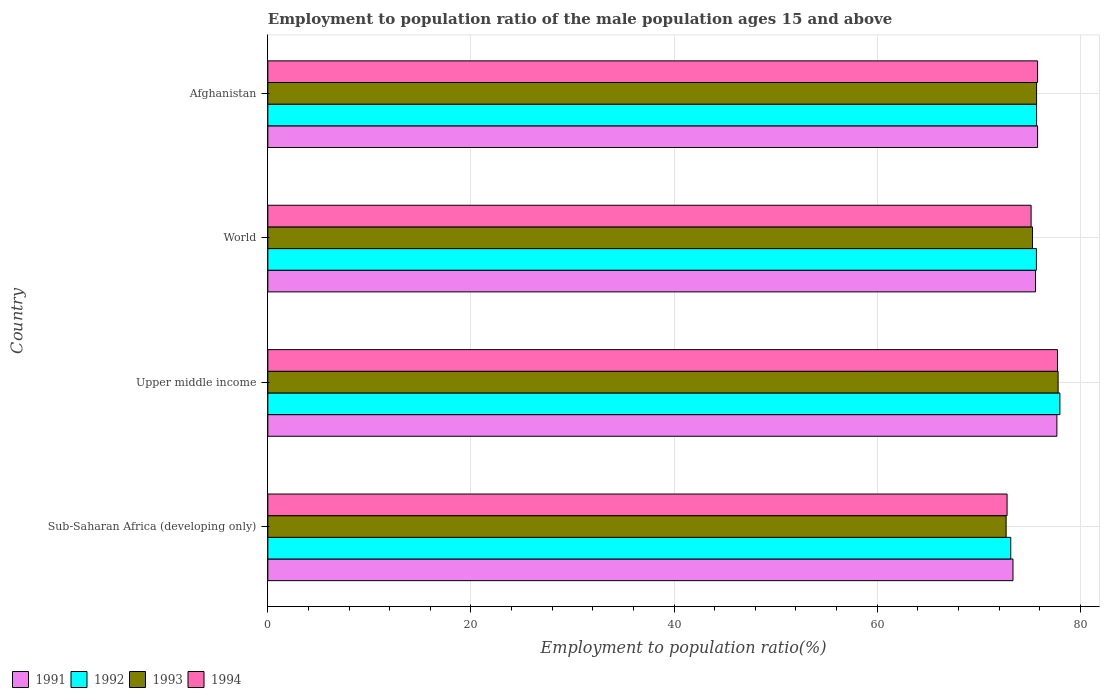How many groups of bars are there?
Make the answer very short. 4. Are the number of bars per tick equal to the number of legend labels?
Your answer should be compact. Yes. Are the number of bars on each tick of the Y-axis equal?
Make the answer very short. Yes. How many bars are there on the 3rd tick from the top?
Make the answer very short. 4. What is the label of the 4th group of bars from the top?
Your answer should be compact. Sub-Saharan Africa (developing only). In how many cases, is the number of bars for a given country not equal to the number of legend labels?
Provide a succinct answer. 0. What is the employment to population ratio in 1994 in World?
Give a very brief answer. 75.16. Across all countries, what is the maximum employment to population ratio in 1992?
Offer a very short reply. 78. Across all countries, what is the minimum employment to population ratio in 1991?
Offer a terse response. 73.38. In which country was the employment to population ratio in 1993 maximum?
Your answer should be very brief. Upper middle income. In which country was the employment to population ratio in 1993 minimum?
Provide a short and direct response. Sub-Saharan Africa (developing only). What is the total employment to population ratio in 1993 in the graph?
Provide a short and direct response. 301.52. What is the difference between the employment to population ratio in 1993 in Sub-Saharan Africa (developing only) and that in Upper middle income?
Ensure brevity in your answer.  -5.12. What is the difference between the employment to population ratio in 1994 in Sub-Saharan Africa (developing only) and the employment to population ratio in 1992 in World?
Ensure brevity in your answer.  -2.89. What is the average employment to population ratio in 1994 per country?
Keep it short and to the point. 75.38. What is the difference between the employment to population ratio in 1994 and employment to population ratio in 1992 in Sub-Saharan Africa (developing only)?
Make the answer very short. -0.36. In how many countries, is the employment to population ratio in 1991 greater than 52 %?
Offer a terse response. 4. What is the ratio of the employment to population ratio in 1991 in Afghanistan to that in Sub-Saharan Africa (developing only)?
Offer a very short reply. 1.03. Is the employment to population ratio in 1991 in Sub-Saharan Africa (developing only) less than that in World?
Give a very brief answer. Yes. Is the difference between the employment to population ratio in 1994 in Upper middle income and World greater than the difference between the employment to population ratio in 1992 in Upper middle income and World?
Your answer should be compact. Yes. What is the difference between the highest and the second highest employment to population ratio in 1993?
Your answer should be very brief. 2.12. What is the difference between the highest and the lowest employment to population ratio in 1991?
Offer a very short reply. 4.32. In how many countries, is the employment to population ratio in 1991 greater than the average employment to population ratio in 1991 taken over all countries?
Ensure brevity in your answer.  2. Is it the case that in every country, the sum of the employment to population ratio in 1994 and employment to population ratio in 1993 is greater than the sum of employment to population ratio in 1992 and employment to population ratio in 1991?
Make the answer very short. No. What is the difference between two consecutive major ticks on the X-axis?
Your response must be concise. 20. Are the values on the major ticks of X-axis written in scientific E-notation?
Make the answer very short. No. Does the graph contain any zero values?
Keep it short and to the point. No. Does the graph contain grids?
Keep it short and to the point. Yes. What is the title of the graph?
Give a very brief answer. Employment to population ratio of the male population ages 15 and above. Does "1994" appear as one of the legend labels in the graph?
Provide a short and direct response. Yes. What is the label or title of the X-axis?
Keep it short and to the point. Employment to population ratio(%). What is the Employment to population ratio(%) of 1991 in Sub-Saharan Africa (developing only)?
Keep it short and to the point. 73.38. What is the Employment to population ratio(%) in 1992 in Sub-Saharan Africa (developing only)?
Your answer should be very brief. 73.16. What is the Employment to population ratio(%) in 1993 in Sub-Saharan Africa (developing only)?
Your response must be concise. 72.7. What is the Employment to population ratio(%) of 1994 in Sub-Saharan Africa (developing only)?
Your response must be concise. 72.8. What is the Employment to population ratio(%) of 1991 in Upper middle income?
Ensure brevity in your answer.  77.7. What is the Employment to population ratio(%) of 1992 in Upper middle income?
Your answer should be compact. 78. What is the Employment to population ratio(%) of 1993 in Upper middle income?
Make the answer very short. 77.82. What is the Employment to population ratio(%) of 1994 in Upper middle income?
Ensure brevity in your answer.  77.76. What is the Employment to population ratio(%) of 1991 in World?
Offer a very short reply. 75.6. What is the Employment to population ratio(%) of 1992 in World?
Provide a short and direct response. 75.69. What is the Employment to population ratio(%) in 1993 in World?
Provide a short and direct response. 75.3. What is the Employment to population ratio(%) in 1994 in World?
Your answer should be very brief. 75.16. What is the Employment to population ratio(%) in 1991 in Afghanistan?
Make the answer very short. 75.8. What is the Employment to population ratio(%) of 1992 in Afghanistan?
Offer a very short reply. 75.7. What is the Employment to population ratio(%) in 1993 in Afghanistan?
Your answer should be very brief. 75.7. What is the Employment to population ratio(%) in 1994 in Afghanistan?
Provide a short and direct response. 75.8. Across all countries, what is the maximum Employment to population ratio(%) in 1991?
Provide a short and direct response. 77.7. Across all countries, what is the maximum Employment to population ratio(%) in 1992?
Make the answer very short. 78. Across all countries, what is the maximum Employment to population ratio(%) of 1993?
Ensure brevity in your answer.  77.82. Across all countries, what is the maximum Employment to population ratio(%) in 1994?
Your answer should be compact. 77.76. Across all countries, what is the minimum Employment to population ratio(%) of 1991?
Give a very brief answer. 73.38. Across all countries, what is the minimum Employment to population ratio(%) of 1992?
Provide a short and direct response. 73.16. Across all countries, what is the minimum Employment to population ratio(%) of 1993?
Your response must be concise. 72.7. Across all countries, what is the minimum Employment to population ratio(%) in 1994?
Your response must be concise. 72.8. What is the total Employment to population ratio(%) in 1991 in the graph?
Give a very brief answer. 302.47. What is the total Employment to population ratio(%) in 1992 in the graph?
Your answer should be compact. 302.54. What is the total Employment to population ratio(%) of 1993 in the graph?
Ensure brevity in your answer.  301.52. What is the total Employment to population ratio(%) in 1994 in the graph?
Keep it short and to the point. 301.52. What is the difference between the Employment to population ratio(%) in 1991 in Sub-Saharan Africa (developing only) and that in Upper middle income?
Your response must be concise. -4.32. What is the difference between the Employment to population ratio(%) in 1992 in Sub-Saharan Africa (developing only) and that in Upper middle income?
Keep it short and to the point. -4.84. What is the difference between the Employment to population ratio(%) of 1993 in Sub-Saharan Africa (developing only) and that in Upper middle income?
Ensure brevity in your answer.  -5.12. What is the difference between the Employment to population ratio(%) in 1994 in Sub-Saharan Africa (developing only) and that in Upper middle income?
Provide a succinct answer. -4.97. What is the difference between the Employment to population ratio(%) of 1991 in Sub-Saharan Africa (developing only) and that in World?
Your answer should be very brief. -2.22. What is the difference between the Employment to population ratio(%) of 1992 in Sub-Saharan Africa (developing only) and that in World?
Ensure brevity in your answer.  -2.53. What is the difference between the Employment to population ratio(%) in 1993 in Sub-Saharan Africa (developing only) and that in World?
Offer a very short reply. -2.6. What is the difference between the Employment to population ratio(%) in 1994 in Sub-Saharan Africa (developing only) and that in World?
Your answer should be very brief. -2.37. What is the difference between the Employment to population ratio(%) in 1991 in Sub-Saharan Africa (developing only) and that in Afghanistan?
Ensure brevity in your answer.  -2.42. What is the difference between the Employment to population ratio(%) in 1992 in Sub-Saharan Africa (developing only) and that in Afghanistan?
Give a very brief answer. -2.54. What is the difference between the Employment to population ratio(%) in 1993 in Sub-Saharan Africa (developing only) and that in Afghanistan?
Ensure brevity in your answer.  -3. What is the difference between the Employment to population ratio(%) of 1994 in Sub-Saharan Africa (developing only) and that in Afghanistan?
Ensure brevity in your answer.  -3. What is the difference between the Employment to population ratio(%) in 1991 in Upper middle income and that in World?
Offer a terse response. 2.1. What is the difference between the Employment to population ratio(%) of 1992 in Upper middle income and that in World?
Provide a succinct answer. 2.31. What is the difference between the Employment to population ratio(%) of 1993 in Upper middle income and that in World?
Ensure brevity in your answer.  2.52. What is the difference between the Employment to population ratio(%) in 1994 in Upper middle income and that in World?
Offer a very short reply. 2.6. What is the difference between the Employment to population ratio(%) in 1991 in Upper middle income and that in Afghanistan?
Provide a succinct answer. 1.9. What is the difference between the Employment to population ratio(%) in 1992 in Upper middle income and that in Afghanistan?
Offer a terse response. 2.3. What is the difference between the Employment to population ratio(%) in 1993 in Upper middle income and that in Afghanistan?
Your response must be concise. 2.12. What is the difference between the Employment to population ratio(%) of 1994 in Upper middle income and that in Afghanistan?
Give a very brief answer. 1.96. What is the difference between the Employment to population ratio(%) of 1991 in World and that in Afghanistan?
Provide a succinct answer. -0.2. What is the difference between the Employment to population ratio(%) of 1992 in World and that in Afghanistan?
Provide a short and direct response. -0.01. What is the difference between the Employment to population ratio(%) of 1993 in World and that in Afghanistan?
Your answer should be very brief. -0.4. What is the difference between the Employment to population ratio(%) of 1994 in World and that in Afghanistan?
Ensure brevity in your answer.  -0.64. What is the difference between the Employment to population ratio(%) in 1991 in Sub-Saharan Africa (developing only) and the Employment to population ratio(%) in 1992 in Upper middle income?
Your answer should be very brief. -4.62. What is the difference between the Employment to population ratio(%) of 1991 in Sub-Saharan Africa (developing only) and the Employment to population ratio(%) of 1993 in Upper middle income?
Your answer should be compact. -4.44. What is the difference between the Employment to population ratio(%) of 1991 in Sub-Saharan Africa (developing only) and the Employment to population ratio(%) of 1994 in Upper middle income?
Offer a very short reply. -4.39. What is the difference between the Employment to population ratio(%) of 1992 in Sub-Saharan Africa (developing only) and the Employment to population ratio(%) of 1993 in Upper middle income?
Give a very brief answer. -4.66. What is the difference between the Employment to population ratio(%) in 1992 in Sub-Saharan Africa (developing only) and the Employment to population ratio(%) in 1994 in Upper middle income?
Offer a very short reply. -4.61. What is the difference between the Employment to population ratio(%) in 1993 in Sub-Saharan Africa (developing only) and the Employment to population ratio(%) in 1994 in Upper middle income?
Offer a very short reply. -5.06. What is the difference between the Employment to population ratio(%) of 1991 in Sub-Saharan Africa (developing only) and the Employment to population ratio(%) of 1992 in World?
Your answer should be very brief. -2.31. What is the difference between the Employment to population ratio(%) in 1991 in Sub-Saharan Africa (developing only) and the Employment to population ratio(%) in 1993 in World?
Offer a terse response. -1.93. What is the difference between the Employment to population ratio(%) in 1991 in Sub-Saharan Africa (developing only) and the Employment to population ratio(%) in 1994 in World?
Keep it short and to the point. -1.79. What is the difference between the Employment to population ratio(%) in 1992 in Sub-Saharan Africa (developing only) and the Employment to population ratio(%) in 1993 in World?
Your answer should be very brief. -2.14. What is the difference between the Employment to population ratio(%) of 1992 in Sub-Saharan Africa (developing only) and the Employment to population ratio(%) of 1994 in World?
Provide a succinct answer. -2. What is the difference between the Employment to population ratio(%) of 1993 in Sub-Saharan Africa (developing only) and the Employment to population ratio(%) of 1994 in World?
Offer a very short reply. -2.46. What is the difference between the Employment to population ratio(%) in 1991 in Sub-Saharan Africa (developing only) and the Employment to population ratio(%) in 1992 in Afghanistan?
Make the answer very short. -2.32. What is the difference between the Employment to population ratio(%) in 1991 in Sub-Saharan Africa (developing only) and the Employment to population ratio(%) in 1993 in Afghanistan?
Your answer should be very brief. -2.32. What is the difference between the Employment to population ratio(%) in 1991 in Sub-Saharan Africa (developing only) and the Employment to population ratio(%) in 1994 in Afghanistan?
Offer a terse response. -2.42. What is the difference between the Employment to population ratio(%) of 1992 in Sub-Saharan Africa (developing only) and the Employment to population ratio(%) of 1993 in Afghanistan?
Your answer should be very brief. -2.54. What is the difference between the Employment to population ratio(%) of 1992 in Sub-Saharan Africa (developing only) and the Employment to population ratio(%) of 1994 in Afghanistan?
Offer a terse response. -2.64. What is the difference between the Employment to population ratio(%) of 1993 in Sub-Saharan Africa (developing only) and the Employment to population ratio(%) of 1994 in Afghanistan?
Your answer should be compact. -3.1. What is the difference between the Employment to population ratio(%) in 1991 in Upper middle income and the Employment to population ratio(%) in 1992 in World?
Provide a succinct answer. 2.01. What is the difference between the Employment to population ratio(%) of 1991 in Upper middle income and the Employment to population ratio(%) of 1993 in World?
Offer a very short reply. 2.4. What is the difference between the Employment to population ratio(%) of 1991 in Upper middle income and the Employment to population ratio(%) of 1994 in World?
Ensure brevity in your answer.  2.54. What is the difference between the Employment to population ratio(%) of 1992 in Upper middle income and the Employment to population ratio(%) of 1993 in World?
Your answer should be compact. 2.69. What is the difference between the Employment to population ratio(%) of 1992 in Upper middle income and the Employment to population ratio(%) of 1994 in World?
Offer a very short reply. 2.83. What is the difference between the Employment to population ratio(%) in 1993 in Upper middle income and the Employment to population ratio(%) in 1994 in World?
Give a very brief answer. 2.66. What is the difference between the Employment to population ratio(%) in 1991 in Upper middle income and the Employment to population ratio(%) in 1992 in Afghanistan?
Offer a very short reply. 2. What is the difference between the Employment to population ratio(%) of 1991 in Upper middle income and the Employment to population ratio(%) of 1993 in Afghanistan?
Provide a succinct answer. 2. What is the difference between the Employment to population ratio(%) of 1991 in Upper middle income and the Employment to population ratio(%) of 1994 in Afghanistan?
Your answer should be very brief. 1.9. What is the difference between the Employment to population ratio(%) of 1992 in Upper middle income and the Employment to population ratio(%) of 1993 in Afghanistan?
Ensure brevity in your answer.  2.3. What is the difference between the Employment to population ratio(%) in 1992 in Upper middle income and the Employment to population ratio(%) in 1994 in Afghanistan?
Offer a very short reply. 2.2. What is the difference between the Employment to population ratio(%) of 1993 in Upper middle income and the Employment to population ratio(%) of 1994 in Afghanistan?
Provide a succinct answer. 2.02. What is the difference between the Employment to population ratio(%) of 1991 in World and the Employment to population ratio(%) of 1992 in Afghanistan?
Give a very brief answer. -0.1. What is the difference between the Employment to population ratio(%) in 1991 in World and the Employment to population ratio(%) in 1993 in Afghanistan?
Make the answer very short. -0.1. What is the difference between the Employment to population ratio(%) of 1991 in World and the Employment to population ratio(%) of 1994 in Afghanistan?
Give a very brief answer. -0.2. What is the difference between the Employment to population ratio(%) in 1992 in World and the Employment to population ratio(%) in 1993 in Afghanistan?
Make the answer very short. -0.01. What is the difference between the Employment to population ratio(%) in 1992 in World and the Employment to population ratio(%) in 1994 in Afghanistan?
Give a very brief answer. -0.11. What is the difference between the Employment to population ratio(%) in 1993 in World and the Employment to population ratio(%) in 1994 in Afghanistan?
Offer a very short reply. -0.5. What is the average Employment to population ratio(%) in 1991 per country?
Your response must be concise. 75.62. What is the average Employment to population ratio(%) in 1992 per country?
Provide a succinct answer. 75.63. What is the average Employment to population ratio(%) in 1993 per country?
Offer a very short reply. 75.38. What is the average Employment to population ratio(%) of 1994 per country?
Provide a succinct answer. 75.38. What is the difference between the Employment to population ratio(%) in 1991 and Employment to population ratio(%) in 1992 in Sub-Saharan Africa (developing only)?
Offer a very short reply. 0.22. What is the difference between the Employment to population ratio(%) in 1991 and Employment to population ratio(%) in 1993 in Sub-Saharan Africa (developing only)?
Your answer should be very brief. 0.67. What is the difference between the Employment to population ratio(%) in 1991 and Employment to population ratio(%) in 1994 in Sub-Saharan Africa (developing only)?
Keep it short and to the point. 0.58. What is the difference between the Employment to population ratio(%) of 1992 and Employment to population ratio(%) of 1993 in Sub-Saharan Africa (developing only)?
Provide a short and direct response. 0.46. What is the difference between the Employment to population ratio(%) of 1992 and Employment to population ratio(%) of 1994 in Sub-Saharan Africa (developing only)?
Make the answer very short. 0.36. What is the difference between the Employment to population ratio(%) in 1993 and Employment to population ratio(%) in 1994 in Sub-Saharan Africa (developing only)?
Offer a very short reply. -0.09. What is the difference between the Employment to population ratio(%) in 1991 and Employment to population ratio(%) in 1992 in Upper middle income?
Your answer should be compact. -0.3. What is the difference between the Employment to population ratio(%) of 1991 and Employment to population ratio(%) of 1993 in Upper middle income?
Your answer should be very brief. -0.12. What is the difference between the Employment to population ratio(%) in 1991 and Employment to population ratio(%) in 1994 in Upper middle income?
Your answer should be compact. -0.06. What is the difference between the Employment to population ratio(%) of 1992 and Employment to population ratio(%) of 1993 in Upper middle income?
Your answer should be compact. 0.18. What is the difference between the Employment to population ratio(%) of 1992 and Employment to population ratio(%) of 1994 in Upper middle income?
Ensure brevity in your answer.  0.23. What is the difference between the Employment to population ratio(%) of 1993 and Employment to population ratio(%) of 1994 in Upper middle income?
Make the answer very short. 0.06. What is the difference between the Employment to population ratio(%) in 1991 and Employment to population ratio(%) in 1992 in World?
Offer a terse response. -0.09. What is the difference between the Employment to population ratio(%) of 1991 and Employment to population ratio(%) of 1993 in World?
Your response must be concise. 0.29. What is the difference between the Employment to population ratio(%) in 1991 and Employment to population ratio(%) in 1994 in World?
Your answer should be compact. 0.43. What is the difference between the Employment to population ratio(%) of 1992 and Employment to population ratio(%) of 1993 in World?
Ensure brevity in your answer.  0.38. What is the difference between the Employment to population ratio(%) in 1992 and Employment to population ratio(%) in 1994 in World?
Make the answer very short. 0.52. What is the difference between the Employment to population ratio(%) in 1993 and Employment to population ratio(%) in 1994 in World?
Give a very brief answer. 0.14. What is the difference between the Employment to population ratio(%) in 1991 and Employment to population ratio(%) in 1992 in Afghanistan?
Your answer should be compact. 0.1. What is the difference between the Employment to population ratio(%) in 1992 and Employment to population ratio(%) in 1993 in Afghanistan?
Your response must be concise. 0. What is the difference between the Employment to population ratio(%) of 1993 and Employment to population ratio(%) of 1994 in Afghanistan?
Your answer should be compact. -0.1. What is the ratio of the Employment to population ratio(%) in 1991 in Sub-Saharan Africa (developing only) to that in Upper middle income?
Offer a terse response. 0.94. What is the ratio of the Employment to population ratio(%) in 1992 in Sub-Saharan Africa (developing only) to that in Upper middle income?
Make the answer very short. 0.94. What is the ratio of the Employment to population ratio(%) in 1993 in Sub-Saharan Africa (developing only) to that in Upper middle income?
Ensure brevity in your answer.  0.93. What is the ratio of the Employment to population ratio(%) of 1994 in Sub-Saharan Africa (developing only) to that in Upper middle income?
Make the answer very short. 0.94. What is the ratio of the Employment to population ratio(%) in 1991 in Sub-Saharan Africa (developing only) to that in World?
Give a very brief answer. 0.97. What is the ratio of the Employment to population ratio(%) of 1992 in Sub-Saharan Africa (developing only) to that in World?
Provide a succinct answer. 0.97. What is the ratio of the Employment to population ratio(%) of 1993 in Sub-Saharan Africa (developing only) to that in World?
Make the answer very short. 0.97. What is the ratio of the Employment to population ratio(%) in 1994 in Sub-Saharan Africa (developing only) to that in World?
Provide a short and direct response. 0.97. What is the ratio of the Employment to population ratio(%) of 1991 in Sub-Saharan Africa (developing only) to that in Afghanistan?
Give a very brief answer. 0.97. What is the ratio of the Employment to population ratio(%) of 1992 in Sub-Saharan Africa (developing only) to that in Afghanistan?
Your response must be concise. 0.97. What is the ratio of the Employment to population ratio(%) in 1993 in Sub-Saharan Africa (developing only) to that in Afghanistan?
Offer a very short reply. 0.96. What is the ratio of the Employment to population ratio(%) of 1994 in Sub-Saharan Africa (developing only) to that in Afghanistan?
Your answer should be compact. 0.96. What is the ratio of the Employment to population ratio(%) in 1991 in Upper middle income to that in World?
Provide a succinct answer. 1.03. What is the ratio of the Employment to population ratio(%) in 1992 in Upper middle income to that in World?
Your response must be concise. 1.03. What is the ratio of the Employment to population ratio(%) of 1993 in Upper middle income to that in World?
Your response must be concise. 1.03. What is the ratio of the Employment to population ratio(%) in 1994 in Upper middle income to that in World?
Provide a short and direct response. 1.03. What is the ratio of the Employment to population ratio(%) in 1991 in Upper middle income to that in Afghanistan?
Give a very brief answer. 1.03. What is the ratio of the Employment to population ratio(%) in 1992 in Upper middle income to that in Afghanistan?
Ensure brevity in your answer.  1.03. What is the ratio of the Employment to population ratio(%) of 1993 in Upper middle income to that in Afghanistan?
Your response must be concise. 1.03. What is the ratio of the Employment to population ratio(%) in 1994 in Upper middle income to that in Afghanistan?
Offer a terse response. 1.03. What is the ratio of the Employment to population ratio(%) in 1991 in World to that in Afghanistan?
Provide a succinct answer. 1. What is the difference between the highest and the second highest Employment to population ratio(%) of 1991?
Provide a short and direct response. 1.9. What is the difference between the highest and the second highest Employment to population ratio(%) of 1992?
Your response must be concise. 2.3. What is the difference between the highest and the second highest Employment to population ratio(%) in 1993?
Offer a terse response. 2.12. What is the difference between the highest and the second highest Employment to population ratio(%) of 1994?
Your answer should be very brief. 1.96. What is the difference between the highest and the lowest Employment to population ratio(%) in 1991?
Offer a terse response. 4.32. What is the difference between the highest and the lowest Employment to population ratio(%) of 1992?
Provide a succinct answer. 4.84. What is the difference between the highest and the lowest Employment to population ratio(%) of 1993?
Keep it short and to the point. 5.12. What is the difference between the highest and the lowest Employment to population ratio(%) of 1994?
Offer a very short reply. 4.97. 